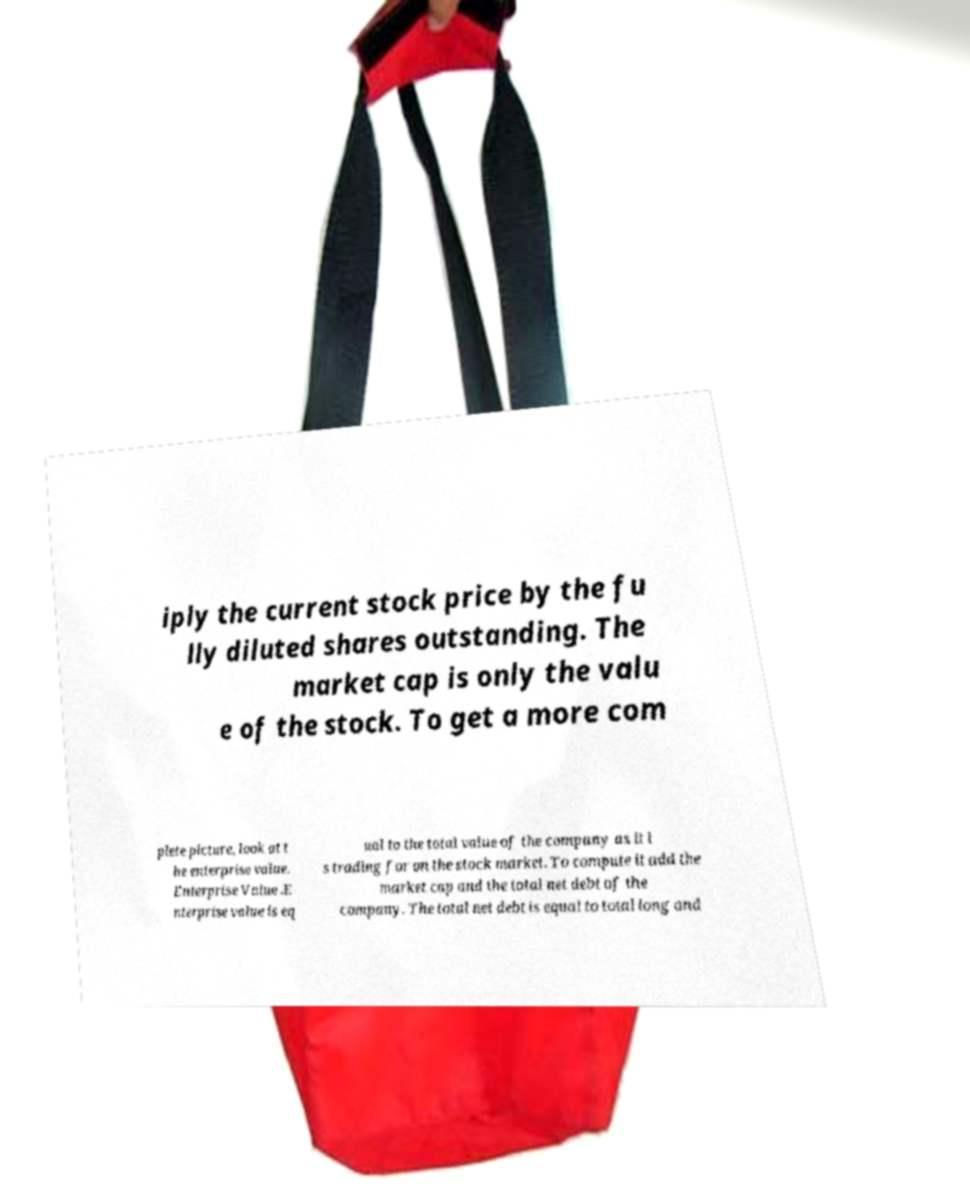I need the written content from this picture converted into text. Can you do that? iply the current stock price by the fu lly diluted shares outstanding. The market cap is only the valu e of the stock. To get a more com plete picture, look at t he enterprise value. Enterprise Value .E nterprise value is eq ual to the total value of the company as it i s trading for on the stock market. To compute it add the market cap and the total net debt of the company. The total net debt is equal to total long and 